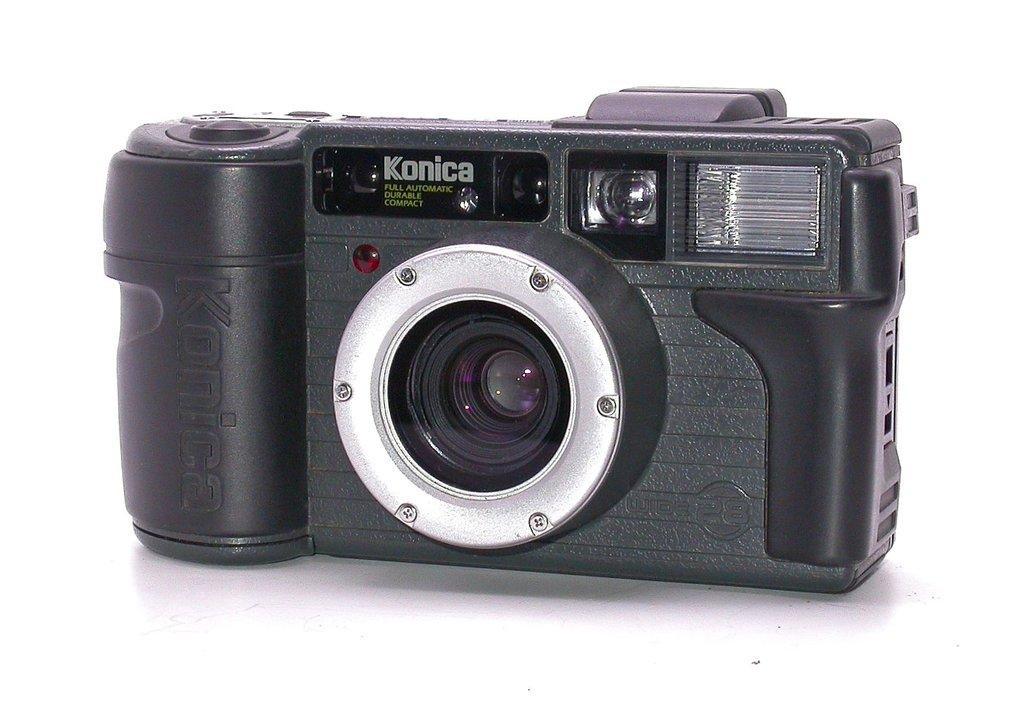Please provide a concise description of this image. In this image we can see a camera placed on the surface. 